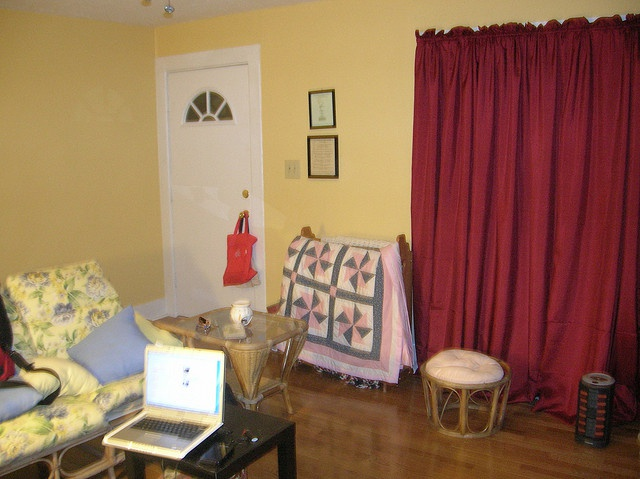Describe the objects in this image and their specific colors. I can see couch in olive, khaki, darkgray, tan, and gray tones, laptop in olive, white, khaki, gray, and tan tones, dining table in olive, gray, tan, and maroon tones, chair in olive, maroon, and tan tones, and keyboard in olive, gray, darkgray, tan, and khaki tones in this image. 